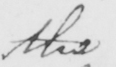Can you tell me what this handwritten text says? the 